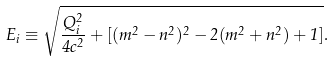<formula> <loc_0><loc_0><loc_500><loc_500>E _ { i } \equiv \sqrt { \frac { Q _ { i } ^ { 2 } } { 4 c ^ { 2 } } + [ ( m ^ { 2 } - n ^ { 2 } ) ^ { 2 } - 2 ( m ^ { 2 } + n ^ { 2 } ) + 1 ] } .</formula> 